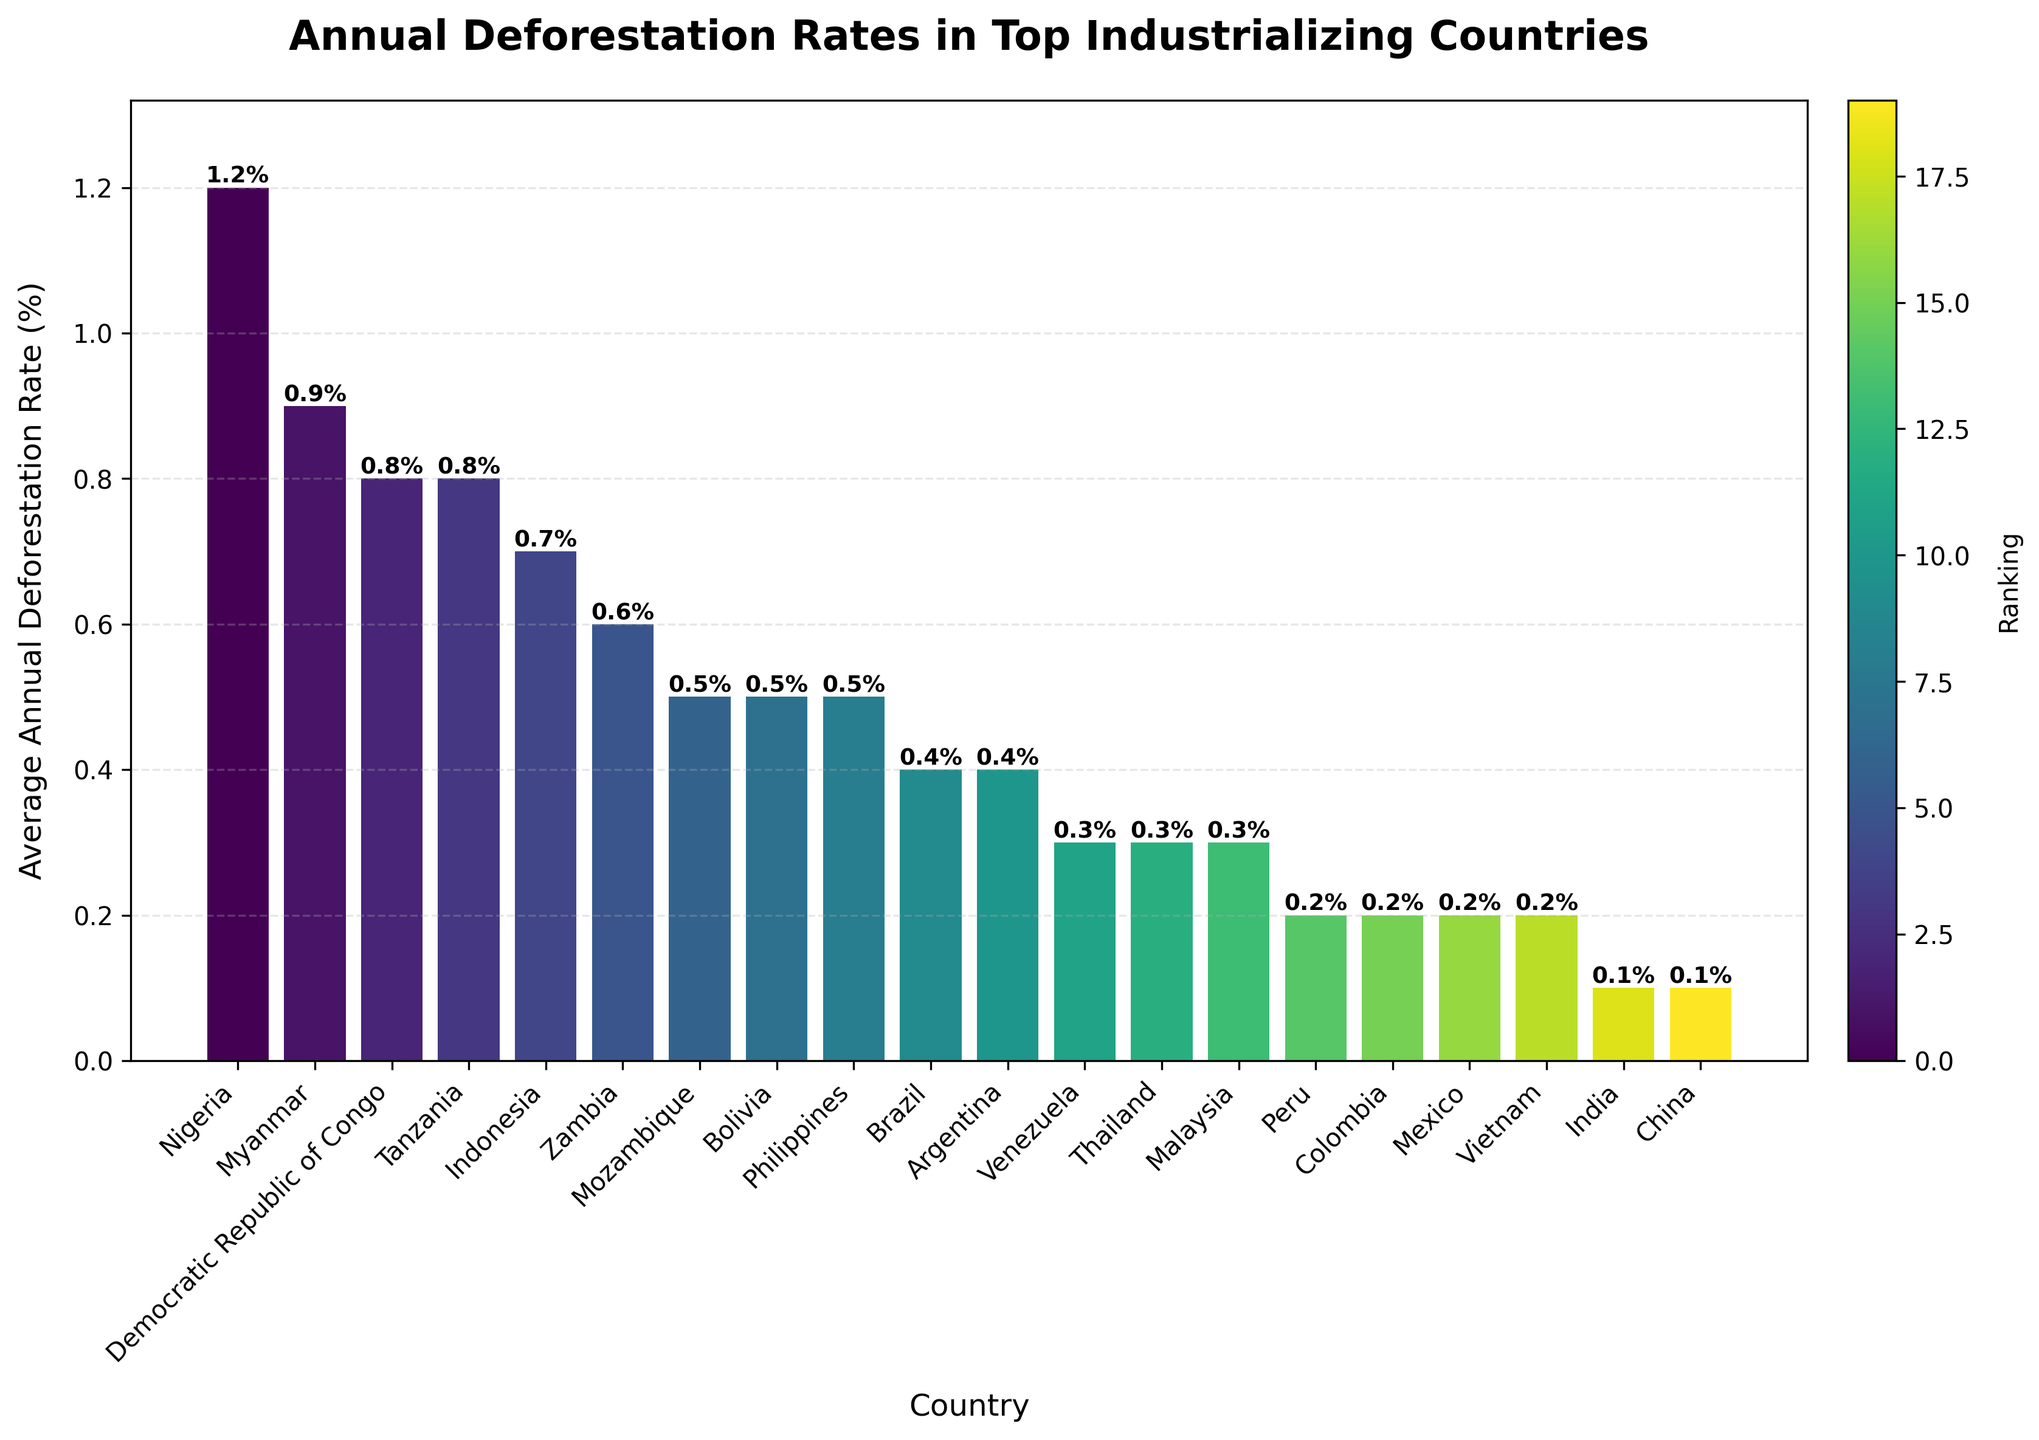what is the country with the highest annual deforestation rate In the bar chart, locate the tallest bar which represents the country with the highest deforestation rate. Each bar is labelled with its country name and deforestation rate.
Answer: Nigeria What is the country with the third-highest deforestation rate? Identify the third tallest bar in the chart and read the country name next to it. Each bar is labeled with its respective country's deforestation rate.
Answer: Myanmar Which country has a deforestation rate of 0.5%? Find the bar with a height labelled 0.5% in the chart and check the country name associated with that bar.
Answer: Philippines and Bolivia Which countries have a deforestation rate less than 0.4%? Observe the bars shorter than the bar that represents the 0.4% rate. The top of each bar has a label showing the deforestation rate and the corresponding country's name.
Answer: Malaysia, Vietnam, India, Mexico, Thailand, Colombia, China, Peru What is the difference in deforestation rates between Indonesia and Brazil? Locate the bars representing Indonesia and Brazil. Note their deforestation rates (0.7% for Indonesia and 0.4% for Brazil). Subtract Brazil's rate from Indonesia's rate: 0.7% - 0.4% = 0.3%.
Answer: 0.3% Which countries have annual deforestation rates equal to or above 0.8%? Identify the bars with values equal to or exceeding 0.8%. Confirm this by checking the labels at the top of these bars.
Answer: DRC, Tanzania, Myanmar, Nigeria What is the average deforestation rate of Malaysia, Thailand, and Argentina? Note the deforestation rates for Malaysia (0.3%), Thailand (0.3%), and Argentina (0.4%). Calculate the average: (0.3 + 0.3 + 0.4) / 3 = 1 / 3 ≈ 0.33%.
Answer: 0.33% Are there more countries with deforestation rates below 0.5% or above 0.5%? Count the number of bars representing countries with deforestation rates below 0.5% and compare it to the count of bars representing countries with rates above 0.5%.
Answer: Below 0.5% How much greater is Nigeria's deforestation rate compared to India's? Find Nigeria's deforestation rate (1.2%) and India's rate (0.1%). Subtract India's rate from Nigeria's: 1.2% - 0.1% = 1.1%.
Answer: 1.1% What are the deforestation rates for the four countries with rates closest to 0.7%? Countries with rates closest to 0.7% are found by looking at the bars near the 0.7% height. Indonesia (0.7%), Myanmar (0.9%), Tanzania (0.8%), and DRC (0.8%).
Answer: 0.7%, 0.9%, 0.8%, 0.8% 